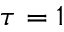<formula> <loc_0><loc_0><loc_500><loc_500>\tau = 1</formula> 